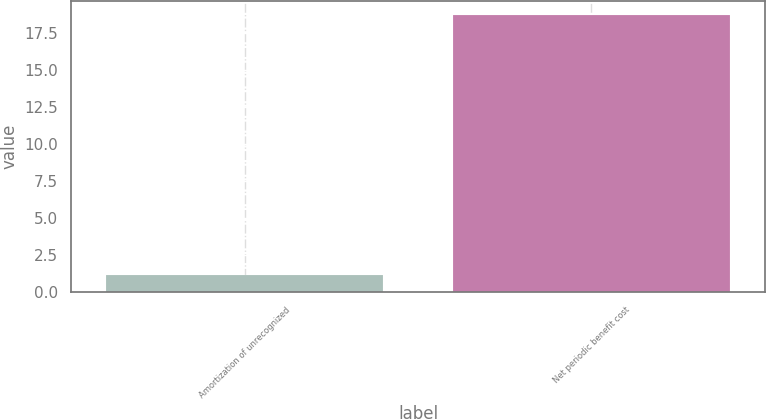Convert chart to OTSL. <chart><loc_0><loc_0><loc_500><loc_500><bar_chart><fcel>Amortization of unrecognized<fcel>Net periodic benefit cost<nl><fcel>1.2<fcel>18.7<nl></chart> 